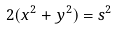Convert formula to latex. <formula><loc_0><loc_0><loc_500><loc_500>2 ( x ^ { 2 } + y ^ { 2 } ) = s ^ { 2 }</formula> 